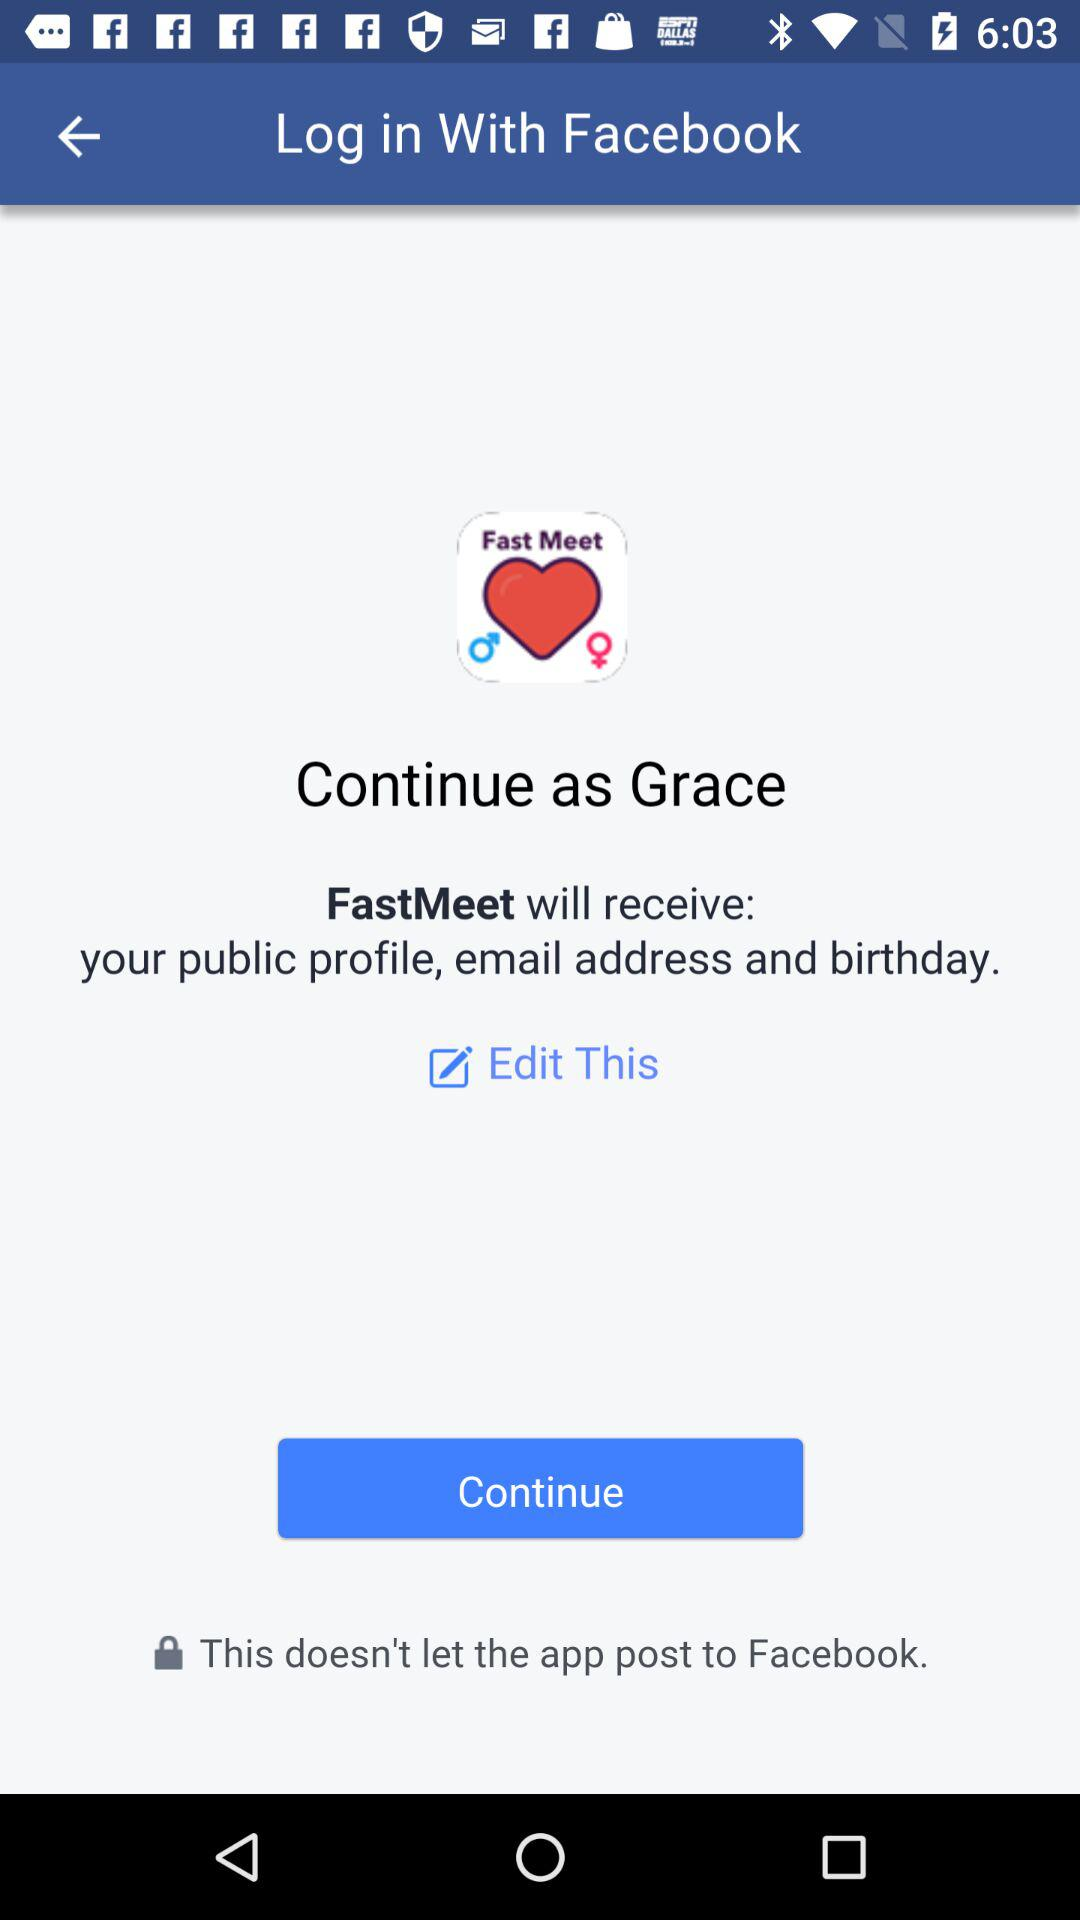Through what account login can be done? Login can be done through the "Facebook" account. 